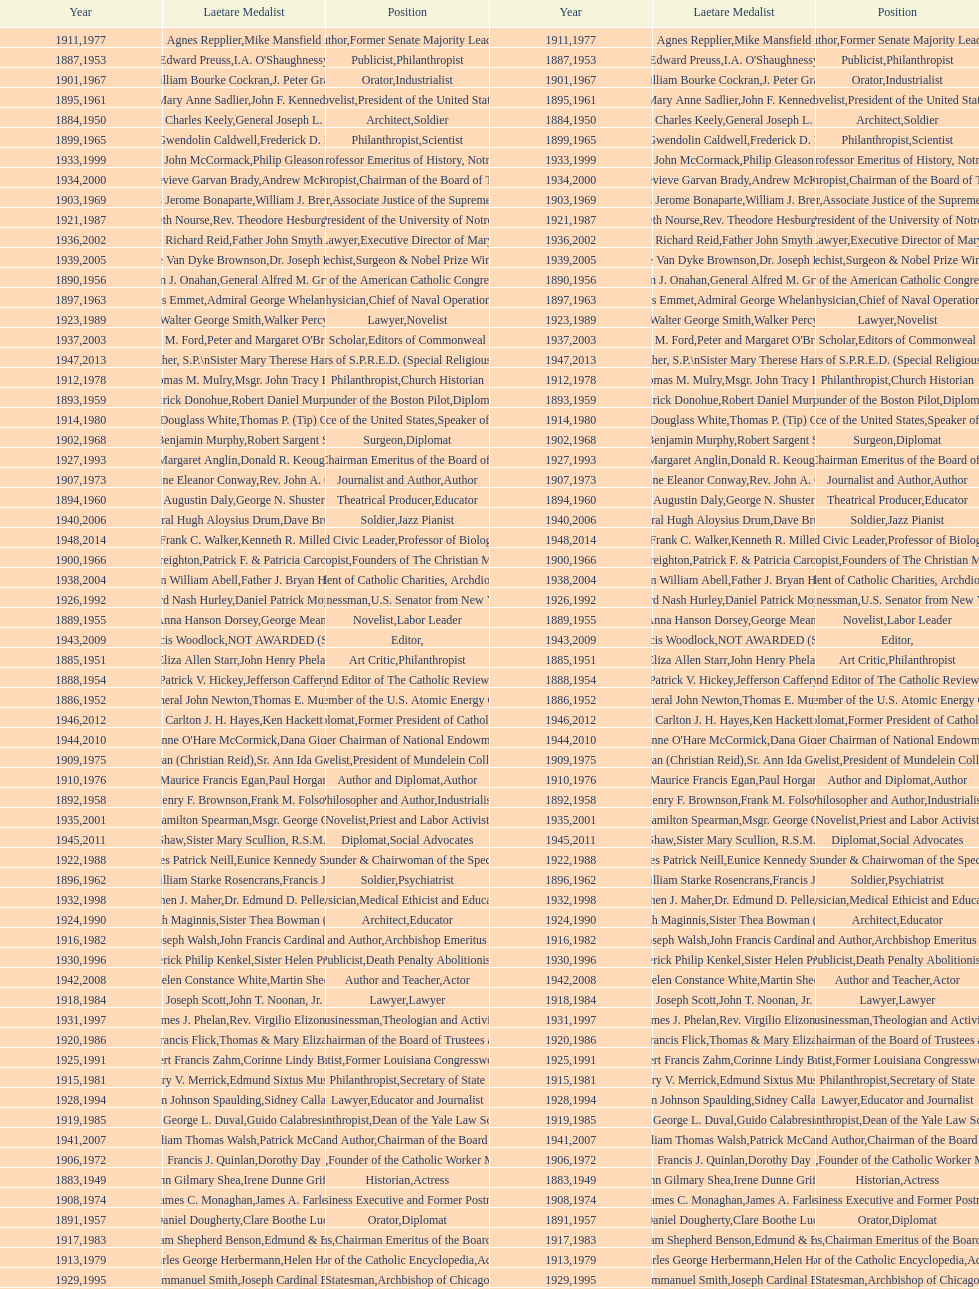How many laetare medalists were philantrohpists? 2. 